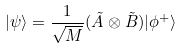<formula> <loc_0><loc_0><loc_500><loc_500>| \psi \rangle = \frac { 1 } { \sqrt { M } } ( \tilde { A } \otimes \tilde { B } ) | \phi ^ { + } \rangle</formula> 